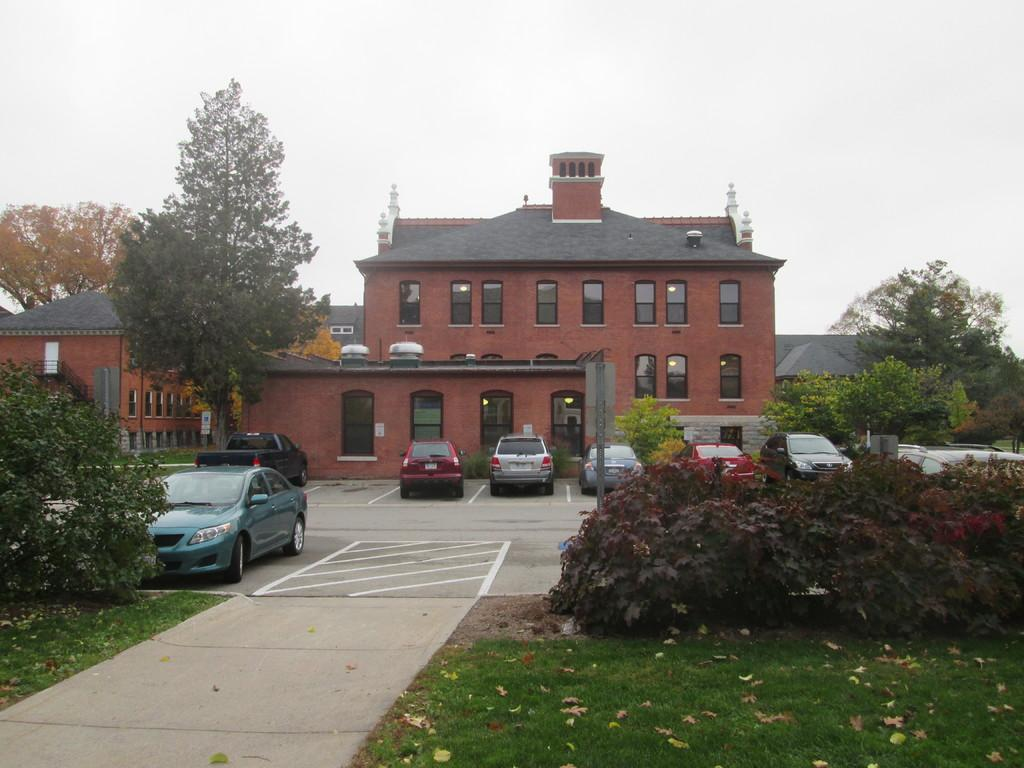What type of vegetation can be seen in the image? There is grass, plants, and trees in the image. What type of structures are present in the image? There are houses in the image. What type of transportation is visible in the image? There are vehicles in the image. What part of the natural environment is visible in the image? The sky is visible in the image. Can you tell me how many times the desk has been touched in the image? There is no desk present in the image, so it is not possible to determine how many times it has been touched. 